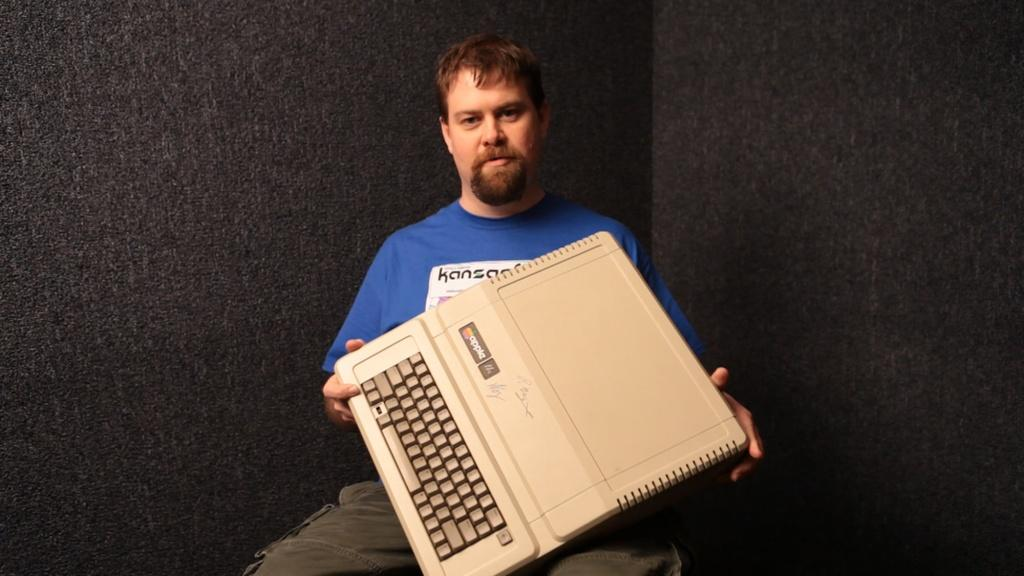What is the main subject of the image? There is a man sitting in the center of the image. What is the man holding in the image? The man is holding a typewriter machine. What can be seen in the background of the image? There is a wall in the background of the image. What type of lamp is hanging from the moon in the image? There is no moon or lamp present in the image. 